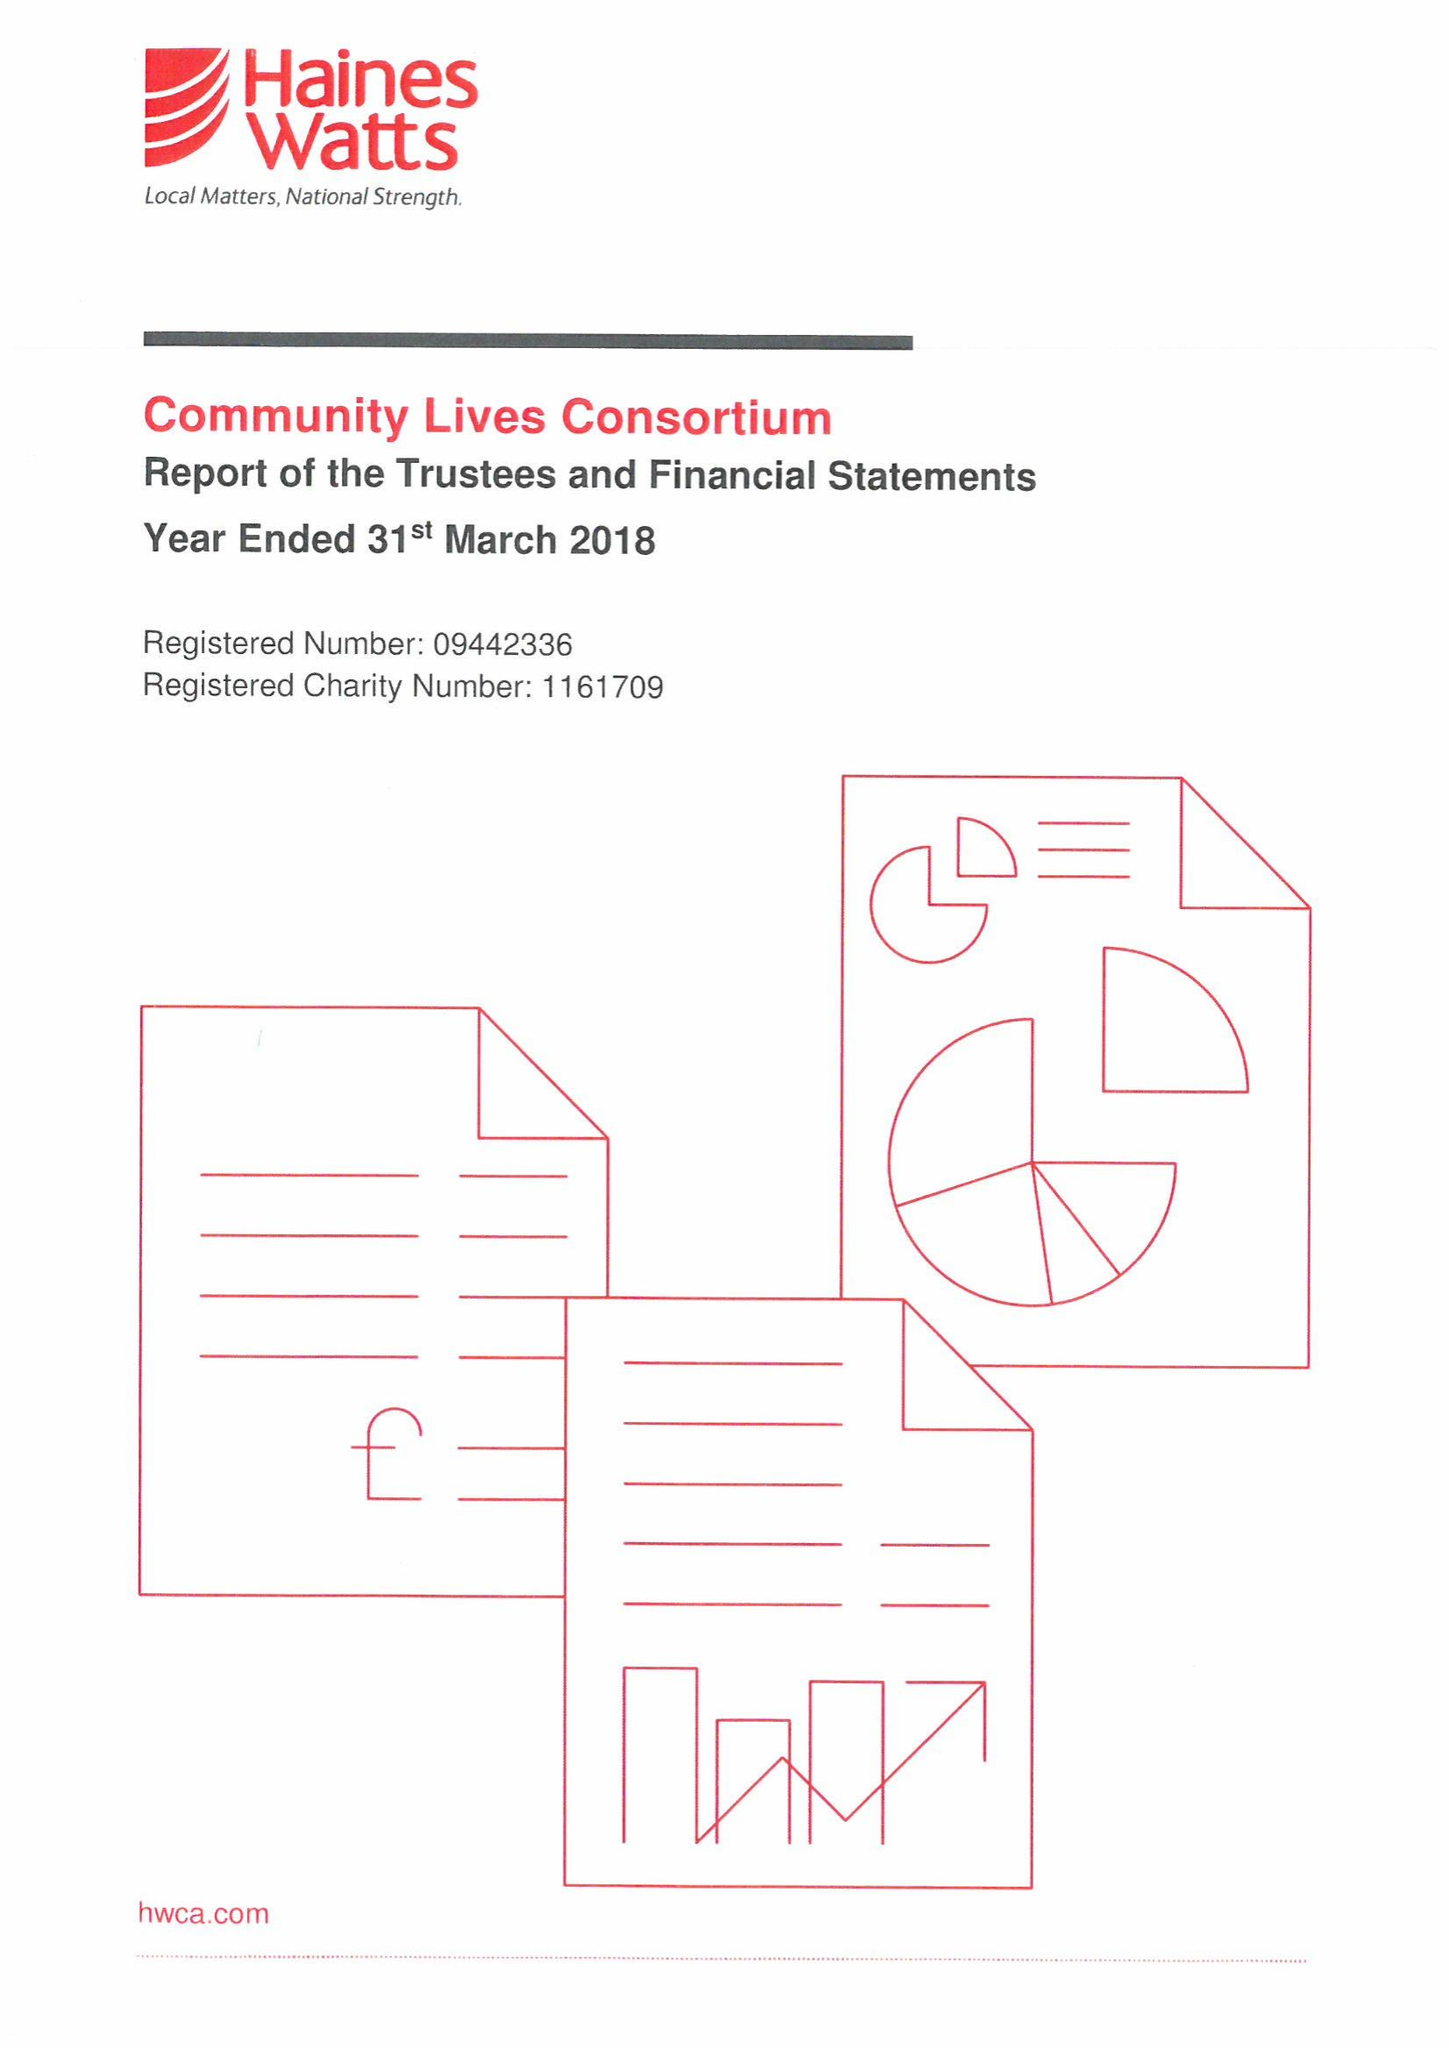What is the value for the address__post_town?
Answer the question using a single word or phrase. SWANSEA 